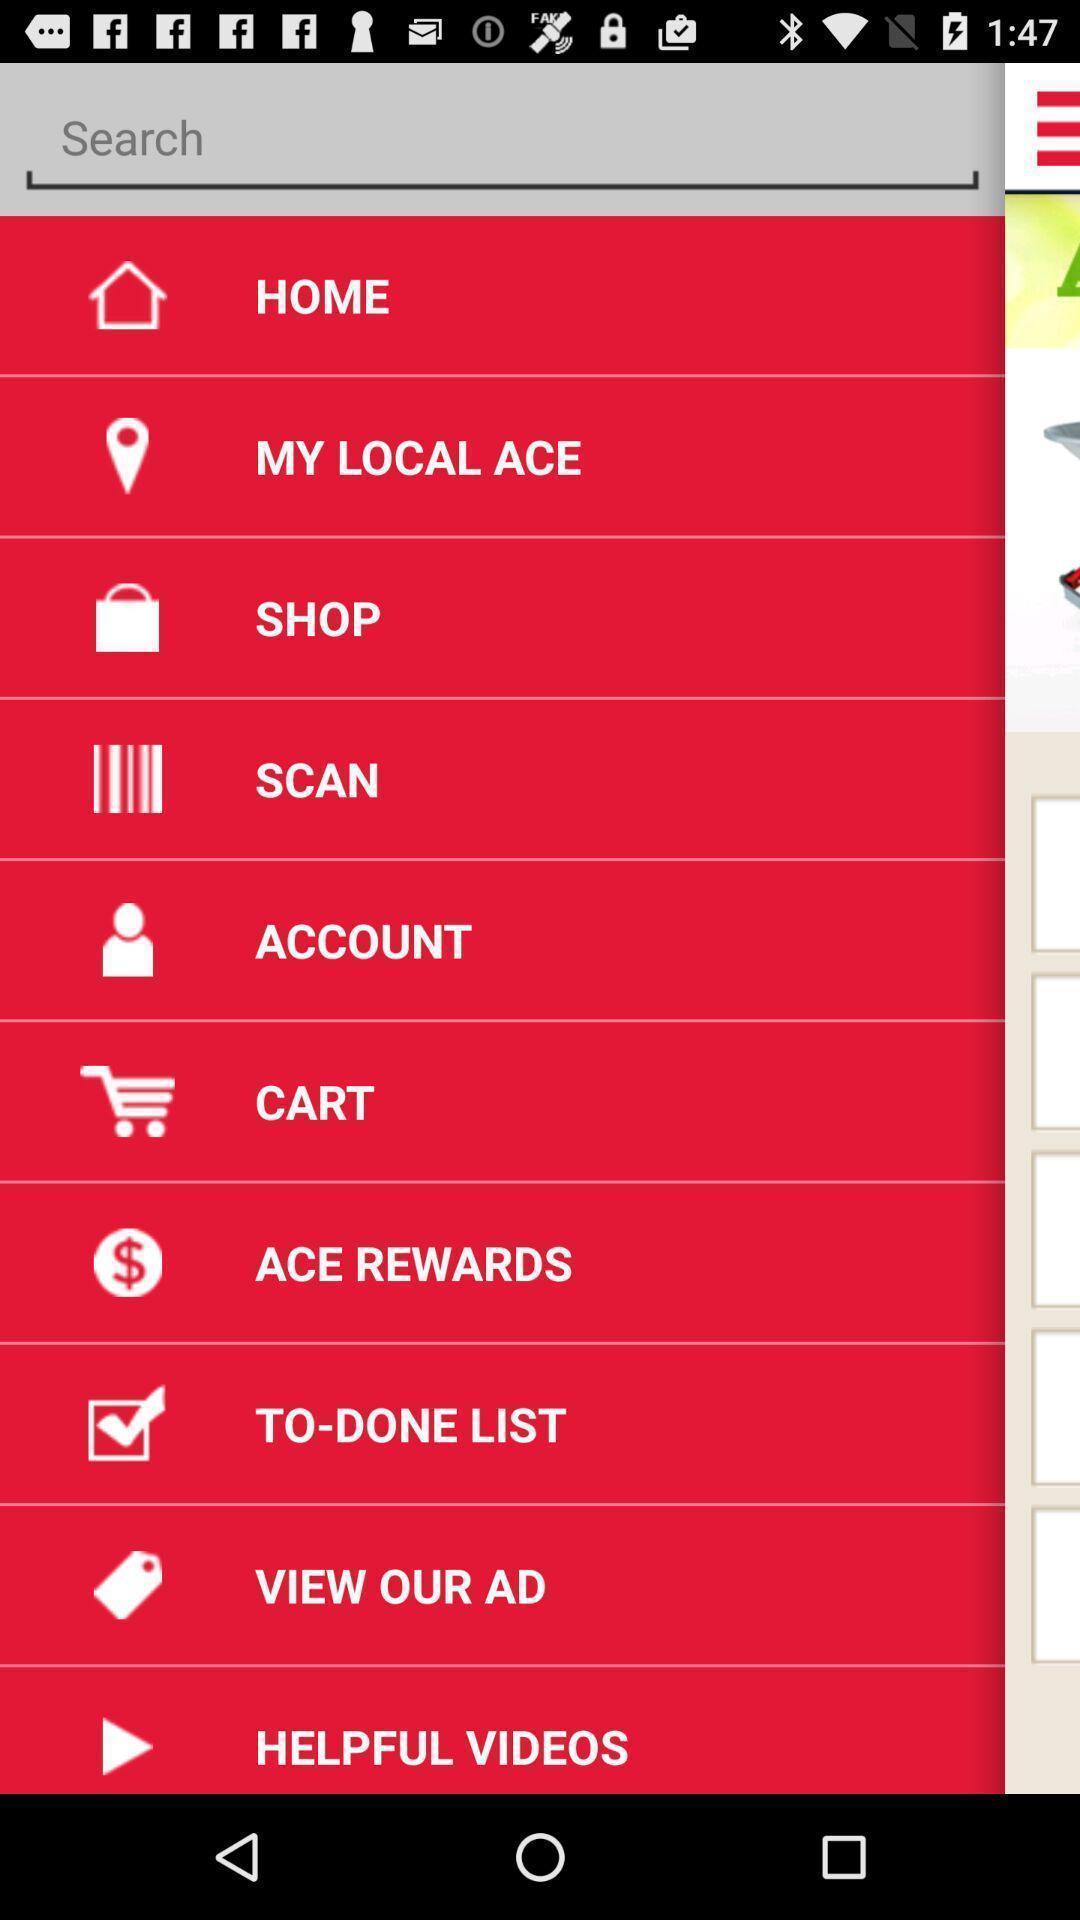Explain what's happening in this screen capture. Screen display list of various options in shopping app. 